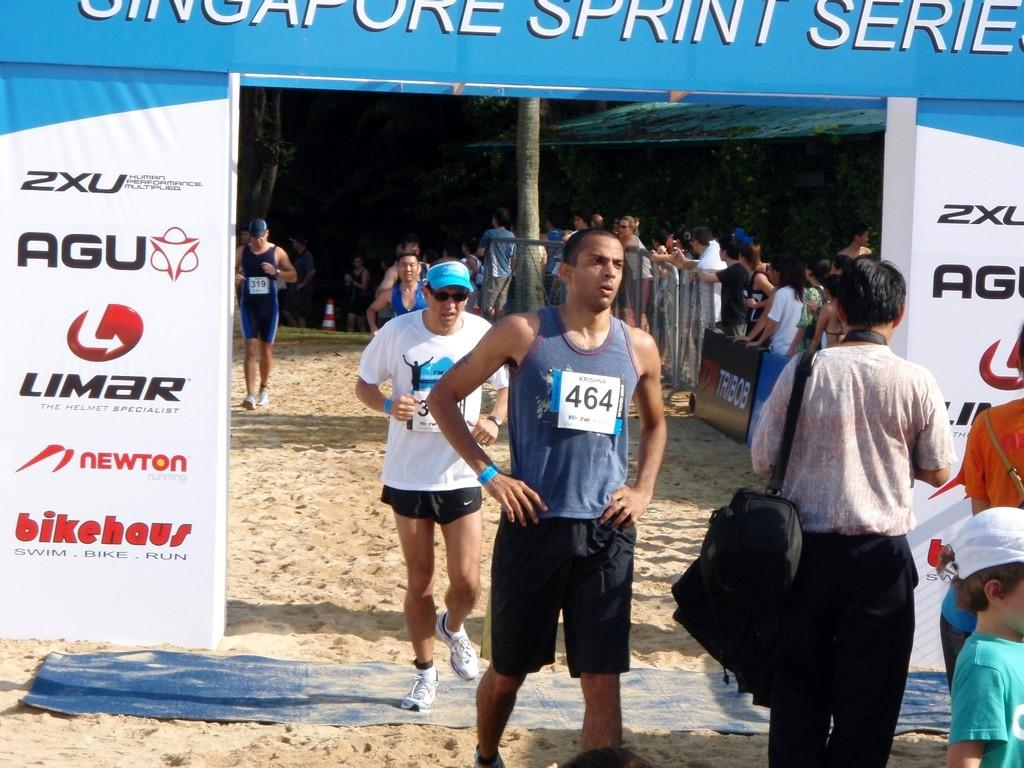What is the main focus of the image? The main focus of the image is the people in the center. What is the purpose of the banner in the image? The purpose of the banner in the image is not clear from the facts provided. What type of surface is at the bottom of the image? There is sand at the bottom of the image. What object is present to ensure safety or caution in the image? There is a safety cone in the image. What type of grain is being harvested by the people in the image? There is no grain present in the image, and the people are not shown performing any agricultural activities. 